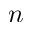<formula> <loc_0><loc_0><loc_500><loc_500>n</formula> 